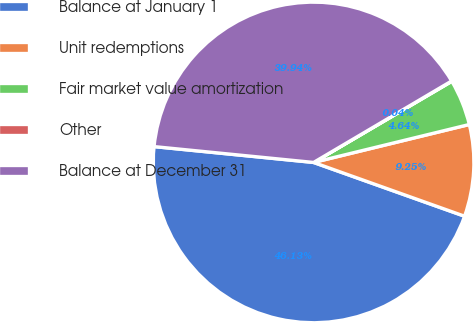Convert chart to OTSL. <chart><loc_0><loc_0><loc_500><loc_500><pie_chart><fcel>Balance at January 1<fcel>Unit redemptions<fcel>Fair market value amortization<fcel>Other<fcel>Balance at December 31<nl><fcel>46.13%<fcel>9.25%<fcel>4.64%<fcel>0.04%<fcel>39.94%<nl></chart> 